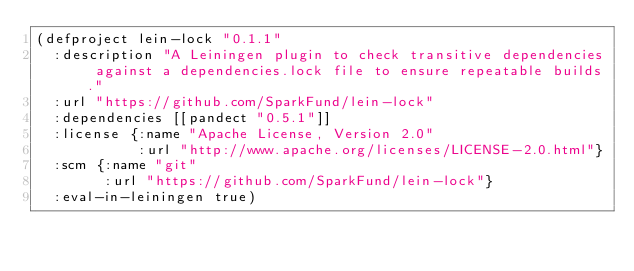Convert code to text. <code><loc_0><loc_0><loc_500><loc_500><_Clojure_>(defproject lein-lock "0.1.1"
  :description "A Leiningen plugin to check transitive dependencies against a dependencies.lock file to ensure repeatable builds."
  :url "https://github.com/SparkFund/lein-lock"
  :dependencies [[pandect "0.5.1"]]
  :license {:name "Apache License, Version 2.0"
            :url "http://www.apache.org/licenses/LICENSE-2.0.html"}
  :scm {:name "git"
        :url "https://github.com/SparkFund/lein-lock"}
  :eval-in-leiningen true)
</code> 